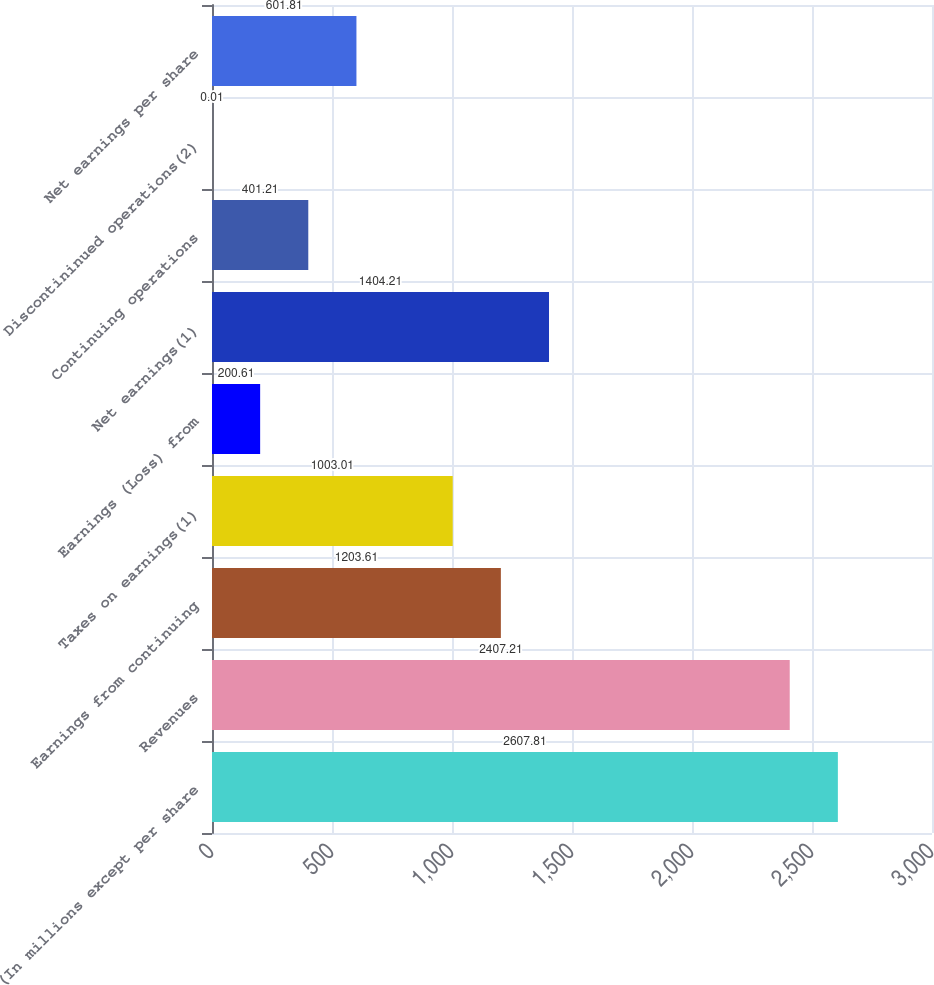Convert chart. <chart><loc_0><loc_0><loc_500><loc_500><bar_chart><fcel>(In millions except per share<fcel>Revenues<fcel>Earnings from continuing<fcel>Taxes on earnings(1)<fcel>Earnings (Loss) from<fcel>Net earnings(1)<fcel>Continuing operations<fcel>Discontininued operations(2)<fcel>Net earnings per share<nl><fcel>2607.81<fcel>2407.21<fcel>1203.61<fcel>1003.01<fcel>200.61<fcel>1404.21<fcel>401.21<fcel>0.01<fcel>601.81<nl></chart> 